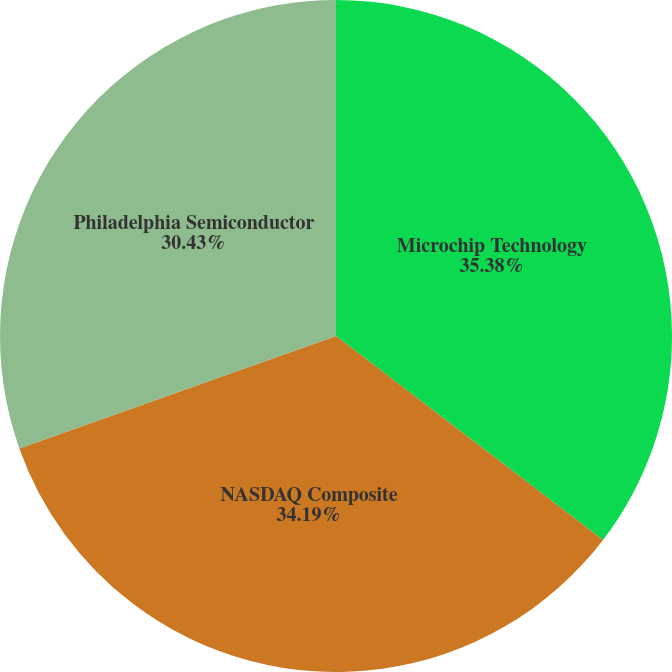Convert chart to OTSL. <chart><loc_0><loc_0><loc_500><loc_500><pie_chart><fcel>Microchip Technology<fcel>NASDAQ Composite<fcel>Philadelphia Semiconductor<nl><fcel>35.38%<fcel>34.19%<fcel>30.43%<nl></chart> 